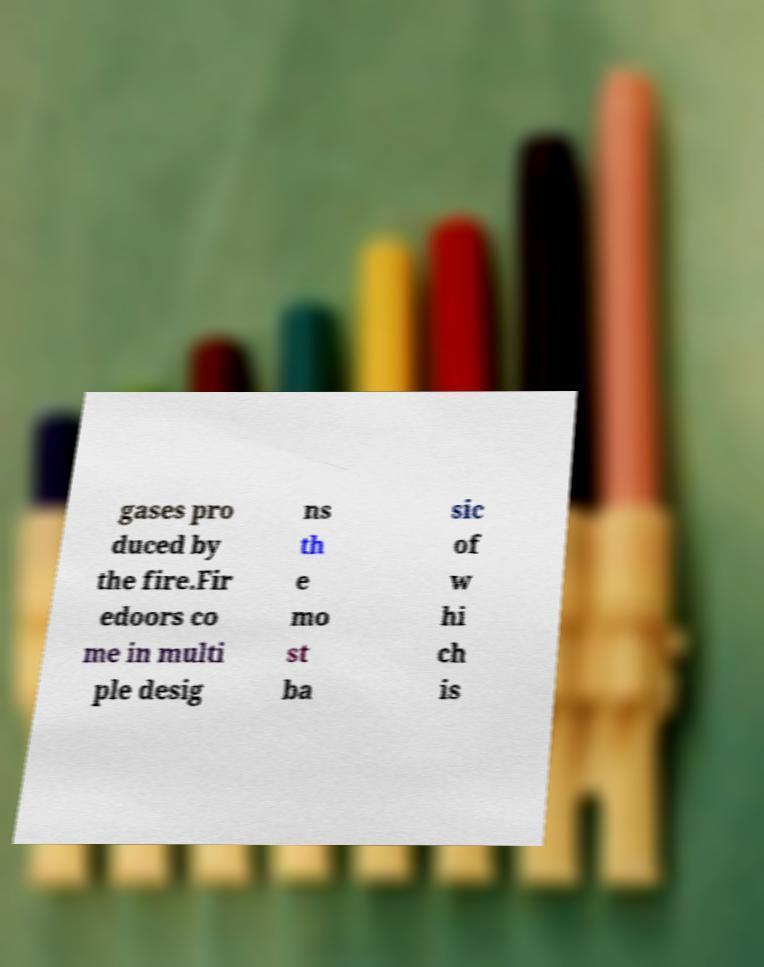Can you read and provide the text displayed in the image?This photo seems to have some interesting text. Can you extract and type it out for me? gases pro duced by the fire.Fir edoors co me in multi ple desig ns th e mo st ba sic of w hi ch is 